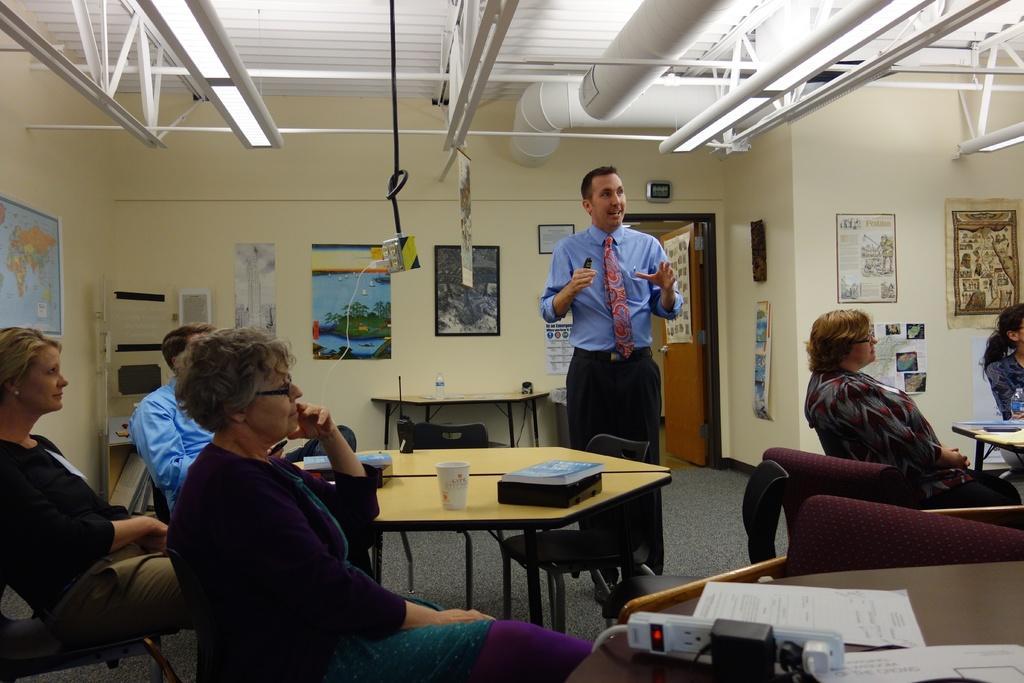In one or two sentences, can you explain what this image depicts? This picture is clicked inside the room. In the middle of the picture, we see a man in blue shirt and black pant is talking. On the left bottom of the picture, we see three people sitting on the chair and in front of them, we see table on which book and glass are placed. On the right corner of the picture, we see two women sitting on chair. Behind them, we see a wall on which many posters are pasted and on background, we see a wall which is yellow in color and we even see many posters pasted on the wall. On the right middle of the picture, we see Atlas pasted on the wall. 